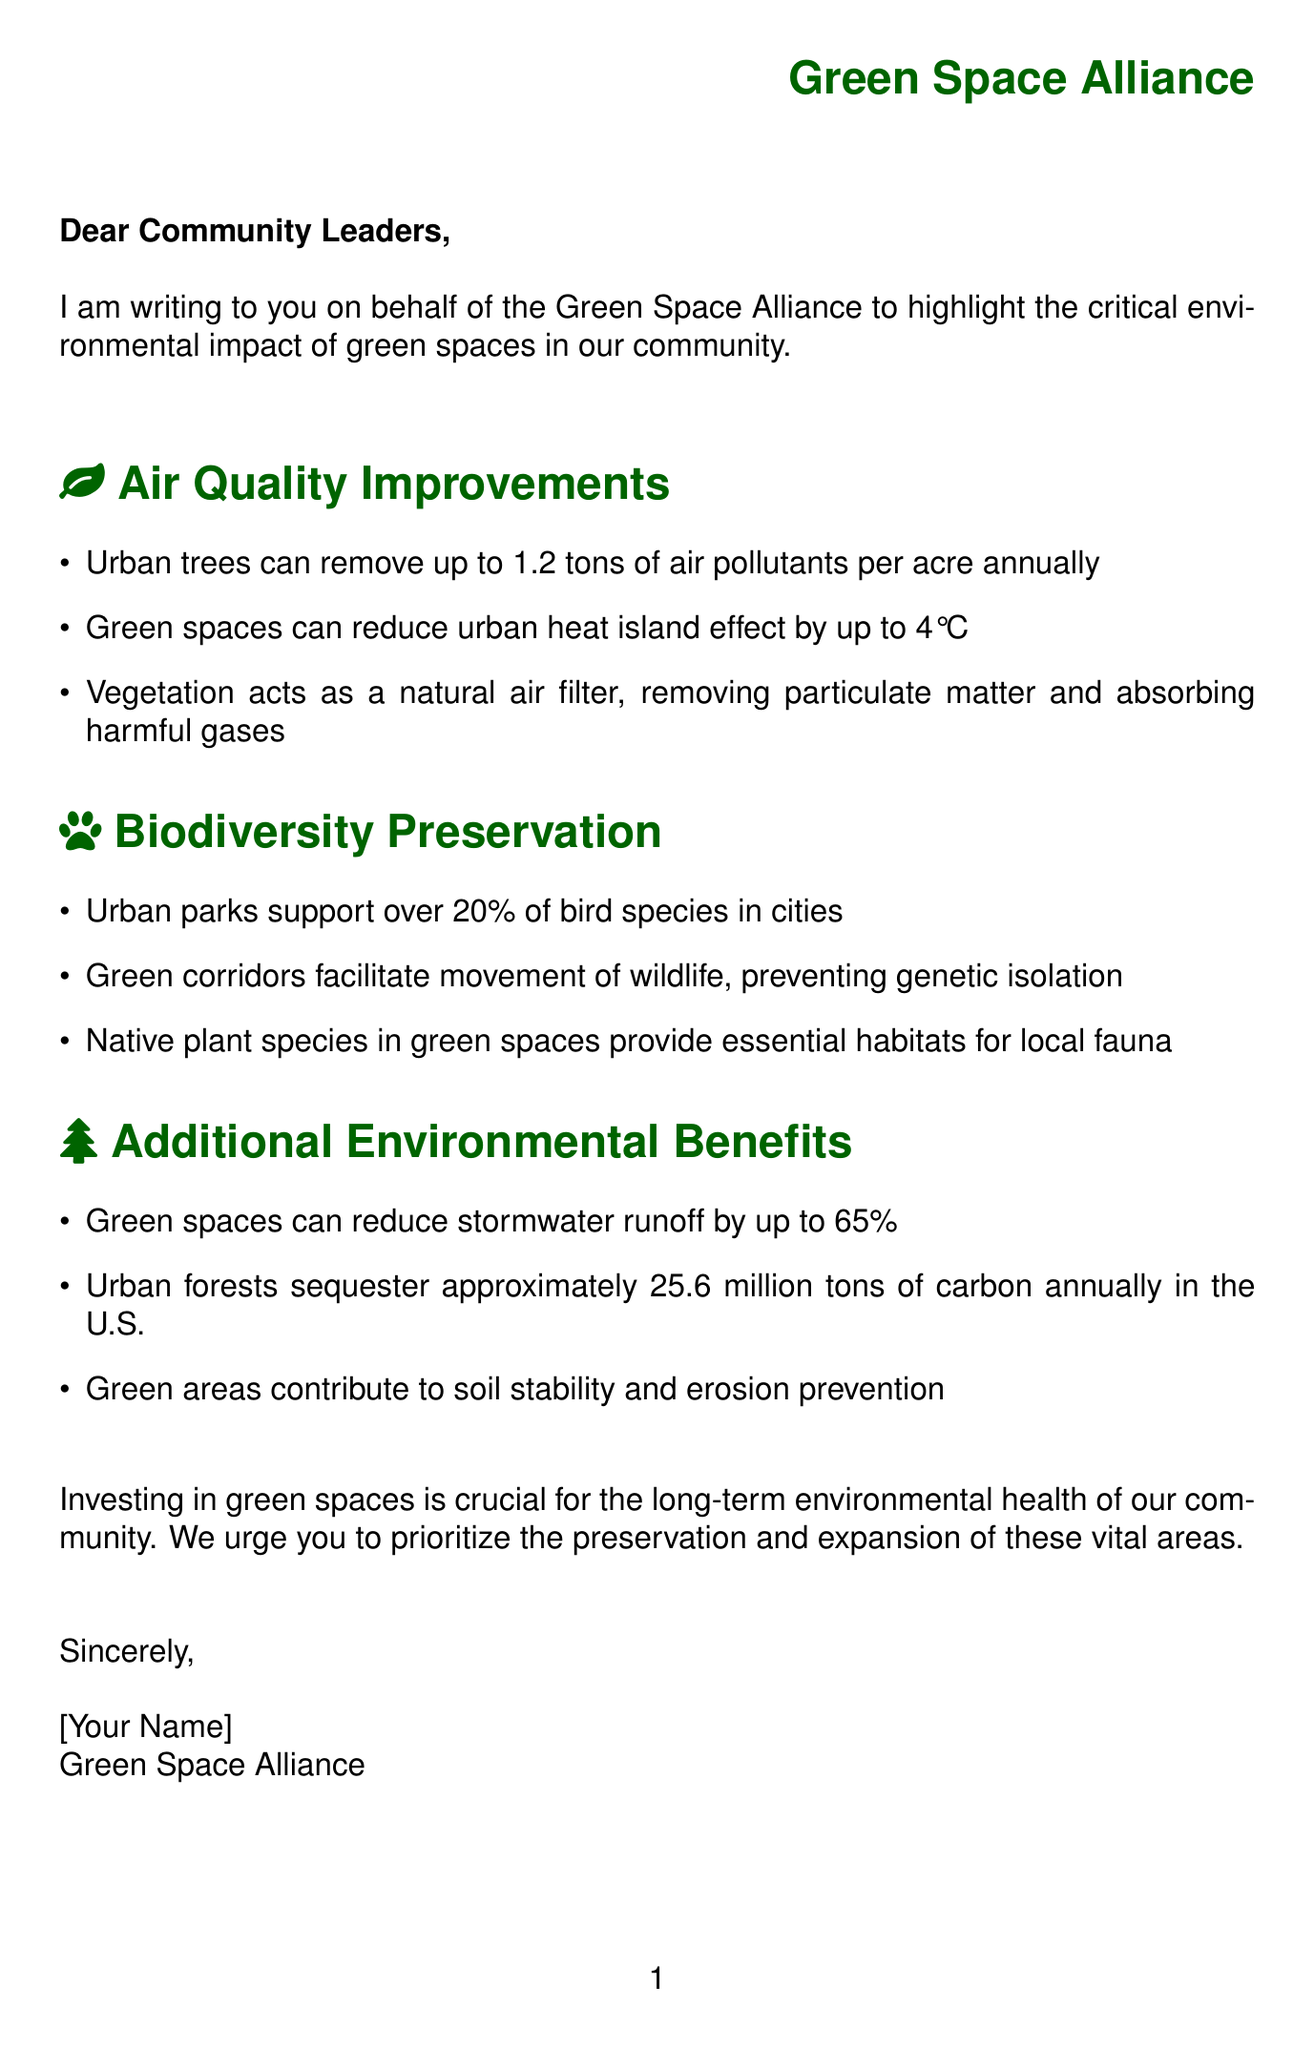What organization is the letter addressed to? The letter is addressed to community leaders, highlighting the intended audience.
Answer: Community Leaders How much can urban trees remove in air pollutants annually? The document specifies the amount of air pollutants that urban trees can remove per acre, which is a numerical value.
Answer: 1.2 tons What effect can green spaces reduce by up to 4°C? The document mentions a specific environmental issue that can be mitigated by green spaces, indicating the degree of reduction.
Answer: Urban heat island effect How many bird species do urban parks support? The letter states a specific percentage of bird species supported by urban parks, indicating their significance in urban biodiversity.
Answer: Over 20% What is one city mentioned that has a successful green space project? The letter provides examples of cities with successful projects, highlighting their relevance to green spaces.
Answer: Singapore What is one immediate step recommended in the call to action? The document includes a list of immediate actions to be taken regarding green spaces, indicating practical measures to be implemented.
Answer: Conduct a comprehensive green space inventory Which organization recommends a minimum of 9 square meters of green space per person? The letter lists important organizations and their relevant recommendations regarding green spaces.
Answer: World Health Organization What is a potential challenge for developing green spaces in urban areas? The letter details challenges that could hinder the development of green spaces, revealing obstacles in this context.
Answer: Limited available land in urban areas 